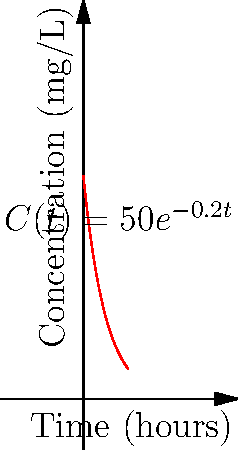As a data scientist analyzing the impact of biotechnologies on healthcare outcomes, you're studying a new drug's concentration in the bloodstream over time. The drug's concentration (in mg/L) is modeled by the function $C(t) = 50e^{-0.2t}$, where $t$ is time in hours. Calculate the total drug exposure (area under the curve) from $t=0$ to $t=10$ hours. Round your answer to the nearest whole number. To solve this problem, we need to calculate the definite integral of the concentration function from $t=0$ to $t=10$. Here's the step-by-step process:

1) The area under the curve is given by the definite integral:

   $\int_0^{10} C(t) dt = \int_0^{10} 50e^{-0.2t} dt$

2) To integrate this, we can use the rule for integrating exponential functions:
   $\int e^{ax} dx = \frac{1}{a}e^{ax} + C$

3) Applying this rule to our integral:

   $\int_0^{10} 50e^{-0.2t} dt = -250e^{-0.2t} \big|_0^{10}$

4) Now we evaluate this from 0 to 10:

   $= -250(e^{-0.2(10)} - e^{-0.2(0)})$
   $= -250(e^{-2} - 1)$

5) Calculate the value:
   $= -250(0.1353 - 1)$
   $= -250(-0.8647)$
   $= 216.175$

6) Rounding to the nearest whole number:
   $216$

Therefore, the total drug exposure over 10 hours is approximately 216 mg·h/L.
Answer: 216 mg·h/L 